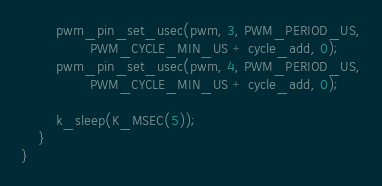<code> <loc_0><loc_0><loc_500><loc_500><_C_>        pwm_pin_set_usec(pwm, 3, PWM_PERIOD_US,
                PWM_CYCLE_MIN_US + cycle_add, 0);
        pwm_pin_set_usec(pwm, 4, PWM_PERIOD_US,
                PWM_CYCLE_MIN_US + cycle_add, 0);

        k_sleep(K_MSEC(5));
    }
}
</code> 